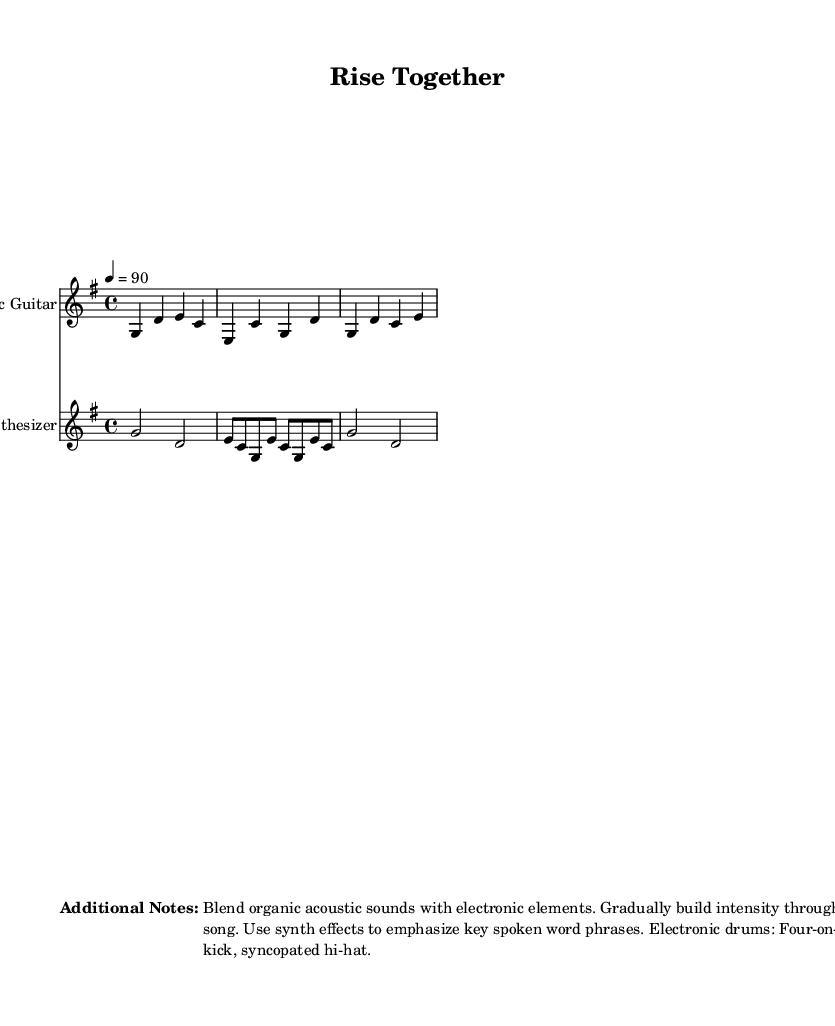What is the key signature of this music? The key signature is G major, which has one sharp (F#) indicated by the key signature at the beginning of the score.
Answer: G major What is the time signature of the piece? The time signature is 4/4, which can be found at the beginning of the score next to the key signature. It indicates four beats in a measure.
Answer: 4/4 What is the tempo marking for this piece? The tempo marking is indicated as 4 = 90, meaning there are 90 beats per minute with a quarter note receiving one beat.
Answer: 90 How many bars are there in the chorus section? The chorus section consists of 2 bars, which can be seen after the verse section, indicated by the rhythmic notation in the score.
Answer: 2 What is the primary instrument used in the introduction? The primary instrument used in the introduction is the Acoustic Guitar, which starts the piece with its own notated melody.
Answer: Acoustic Guitar What electronic sound effect is recommended for emphasizing spoken word phrases? The sheet music notes to use synth effects, specifically highlighting the electronic elements that blend with the acoustic sounds.
Answer: Synth effects What type of rhythm is indicated for the electronic drums? The electronic drums are suggested to follow a four-on-the-floor kick with a syncopated hi-hat rhythm, providing a driving beat typical in indie folk-electronic music.
Answer: Four-on-the-floor kick 